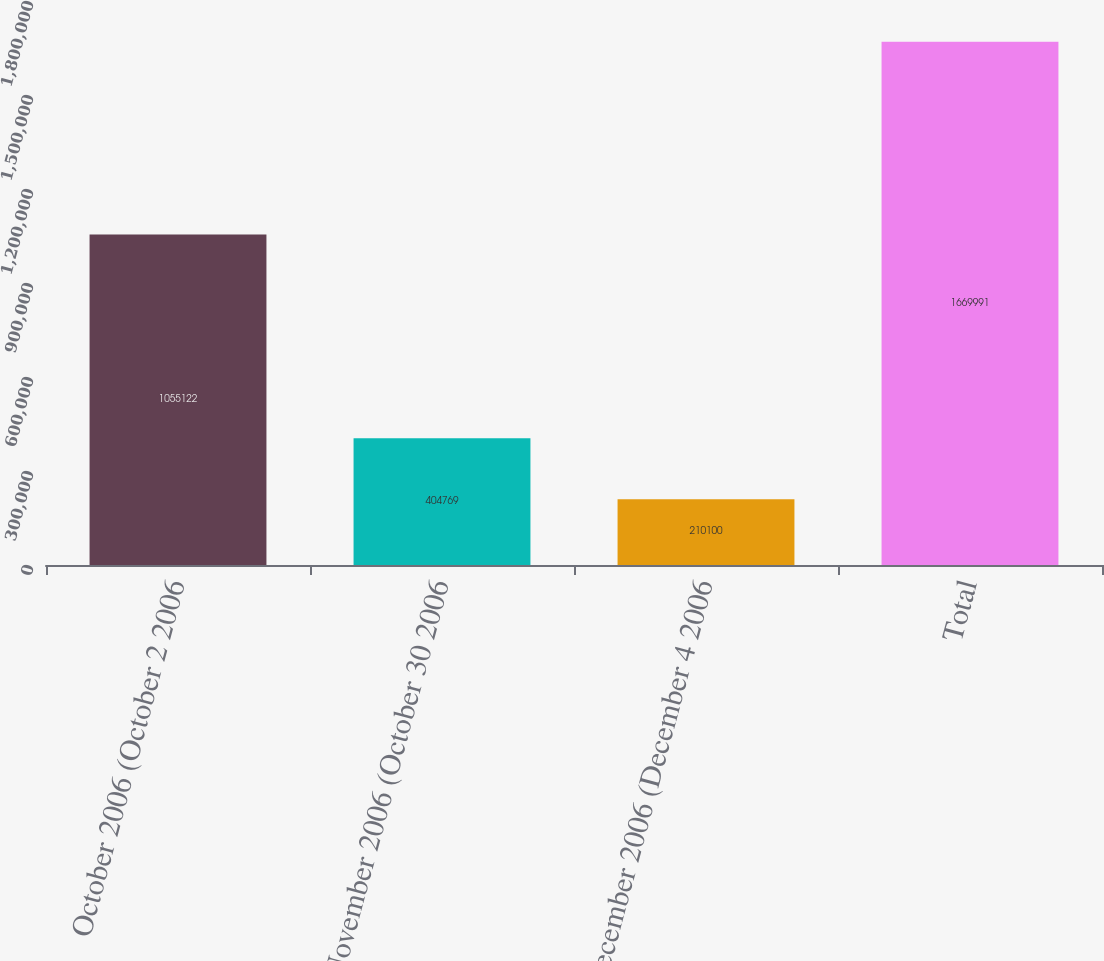Convert chart. <chart><loc_0><loc_0><loc_500><loc_500><bar_chart><fcel>October 2006 (October 2 2006<fcel>November 2006 (October 30 2006<fcel>December 2006 (December 4 2006<fcel>Total<nl><fcel>1.05512e+06<fcel>404769<fcel>210100<fcel>1.66999e+06<nl></chart> 